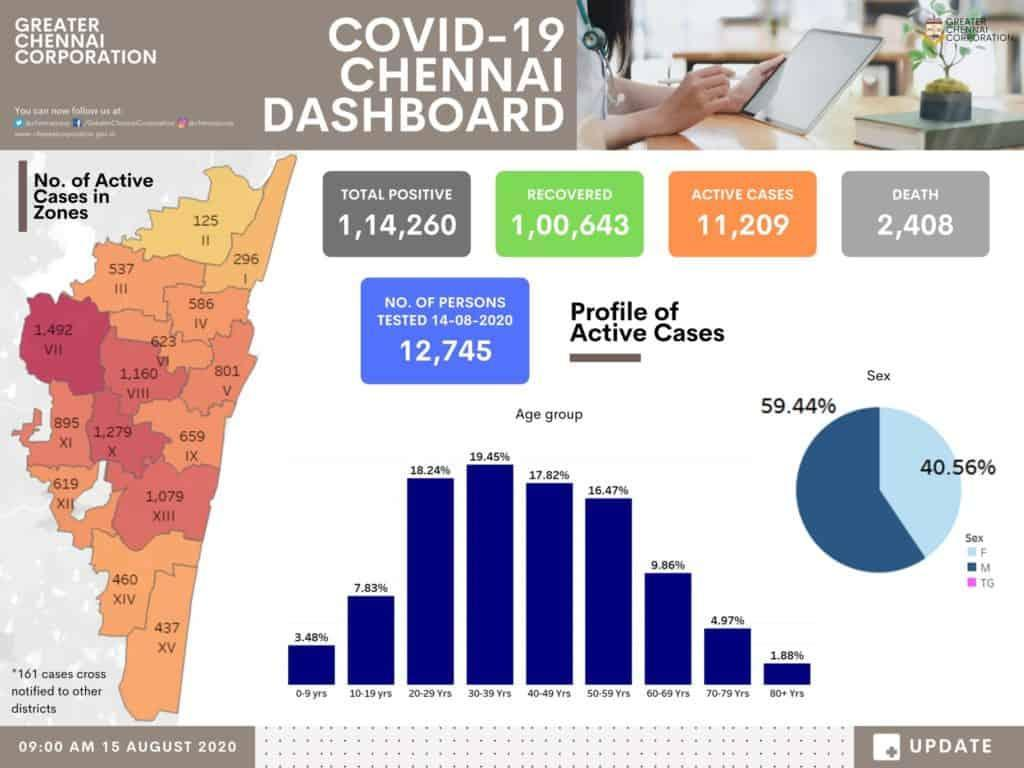What percent of men are active cases?
Answer the question with a short phrase. 59.44% In the profile of active cases, who is represented by 40.56%-Female or male? Female How many people did not survive? 2,408 What percent of people above 60 years were affected? 16.71% 